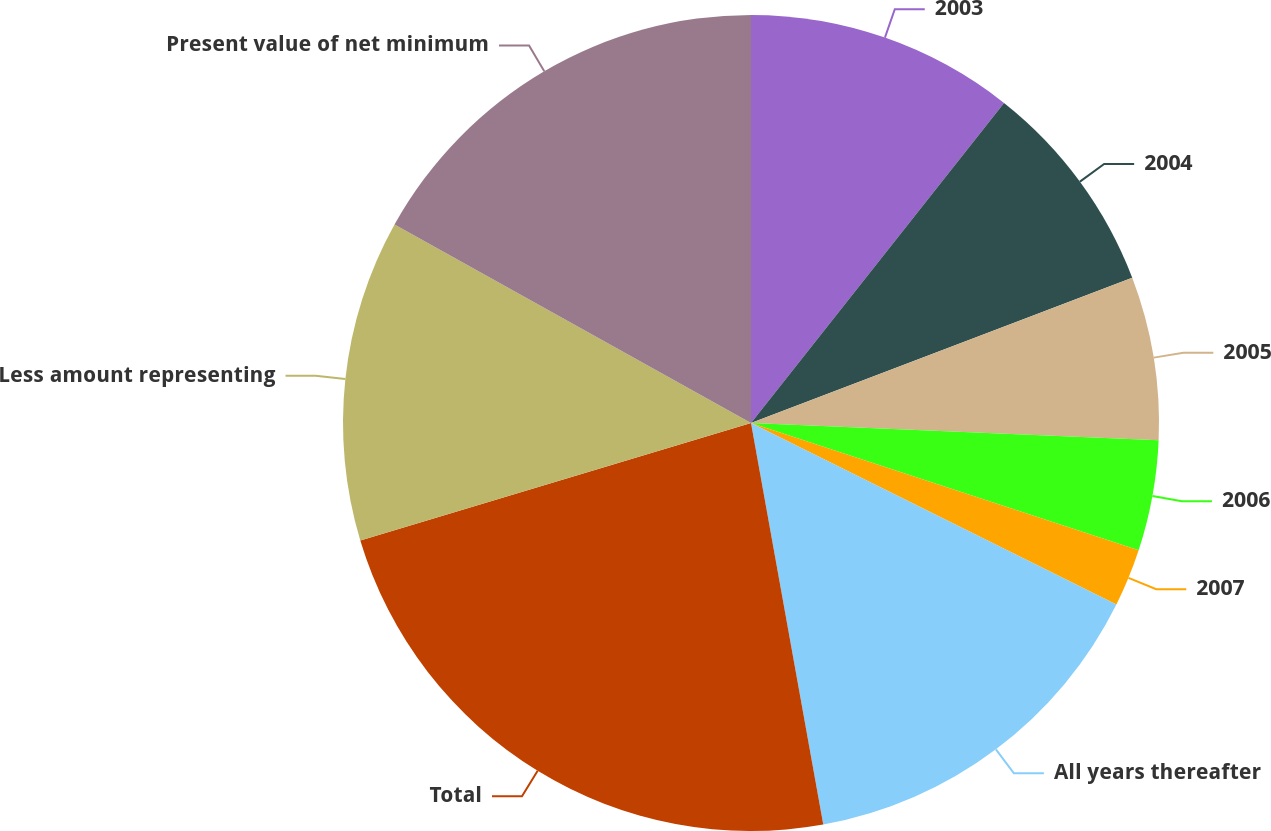<chart> <loc_0><loc_0><loc_500><loc_500><pie_chart><fcel>2003<fcel>2004<fcel>2005<fcel>2006<fcel>2007<fcel>All years thereafter<fcel>Total<fcel>Less amount representing<fcel>Present value of net minimum<nl><fcel>10.65%<fcel>8.56%<fcel>6.47%<fcel>4.38%<fcel>2.29%<fcel>14.83%<fcel>23.19%<fcel>12.74%<fcel>16.92%<nl></chart> 